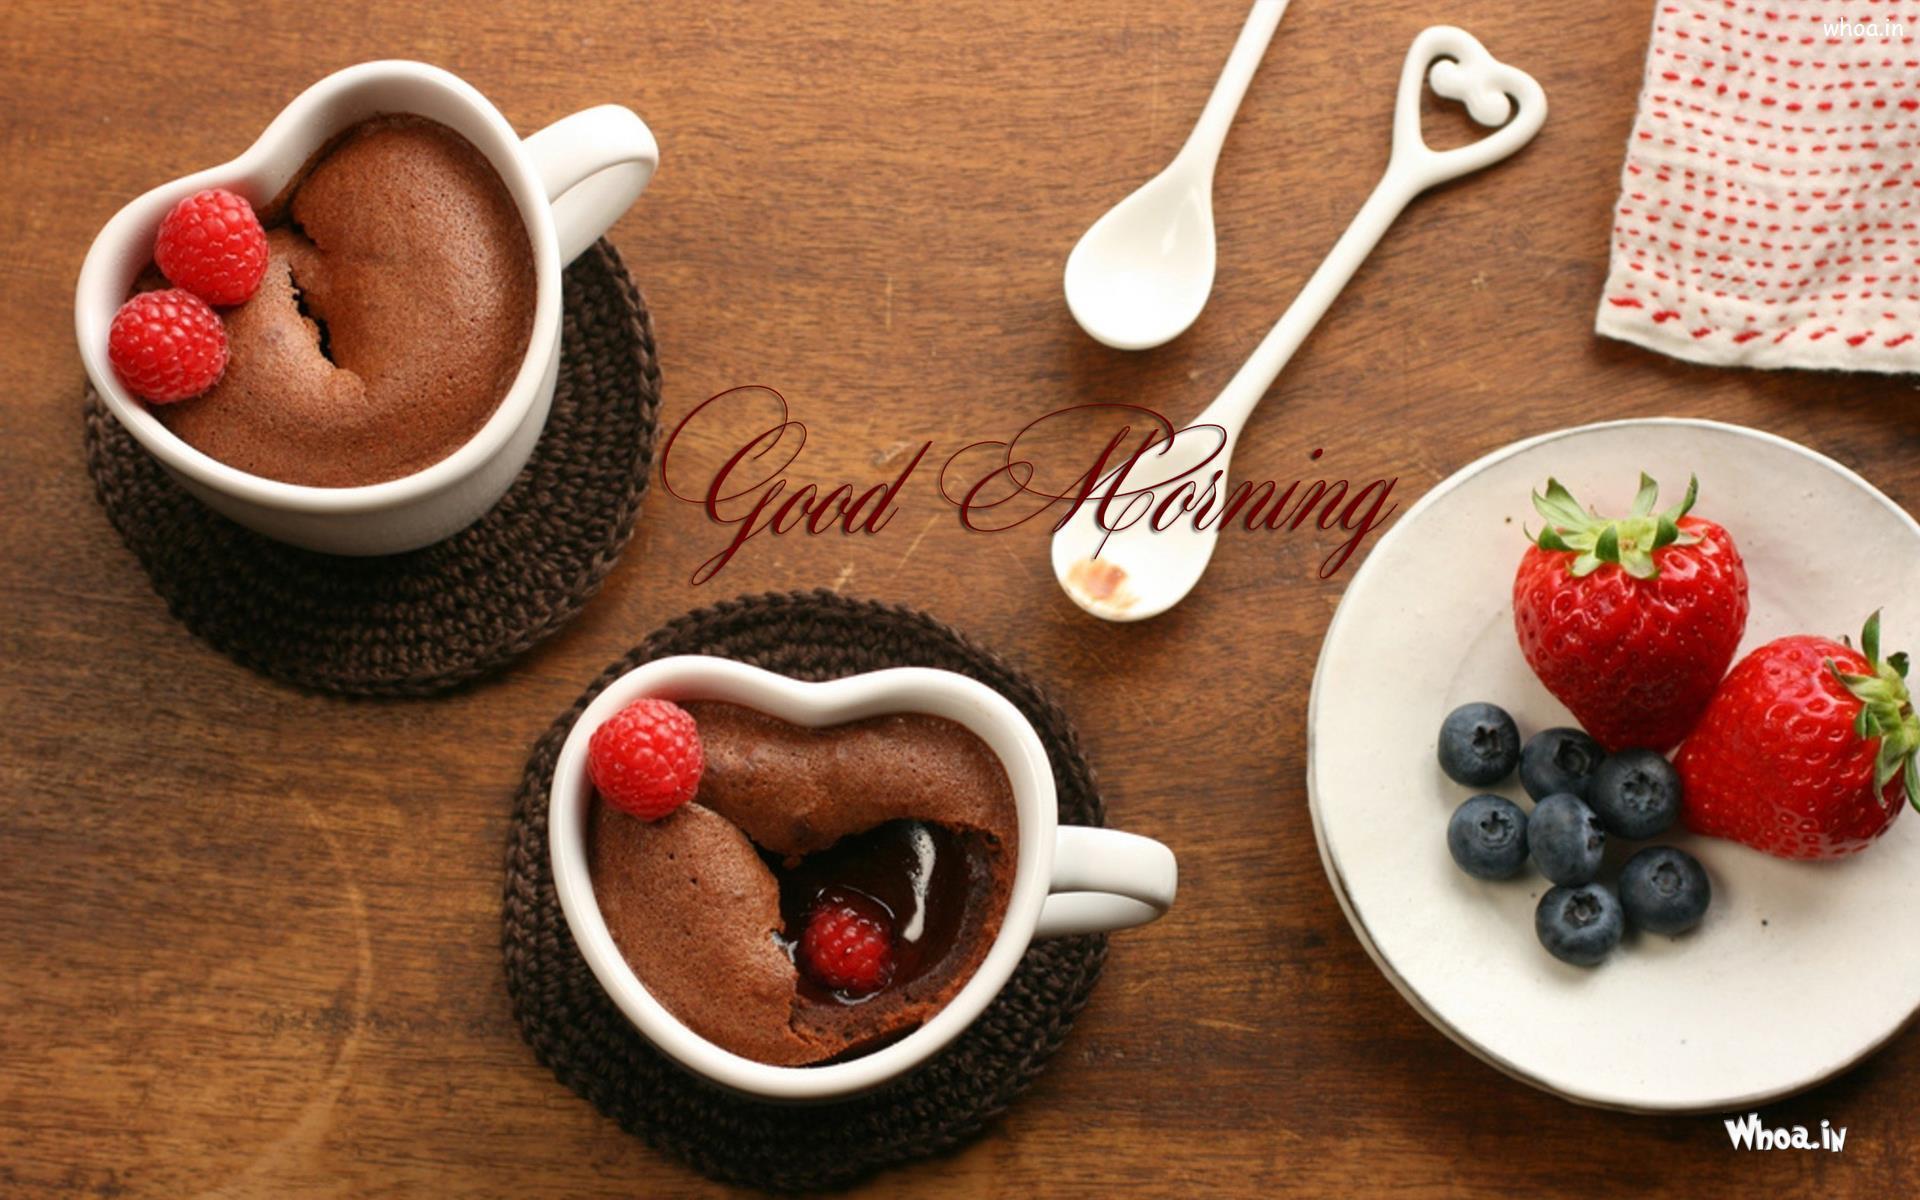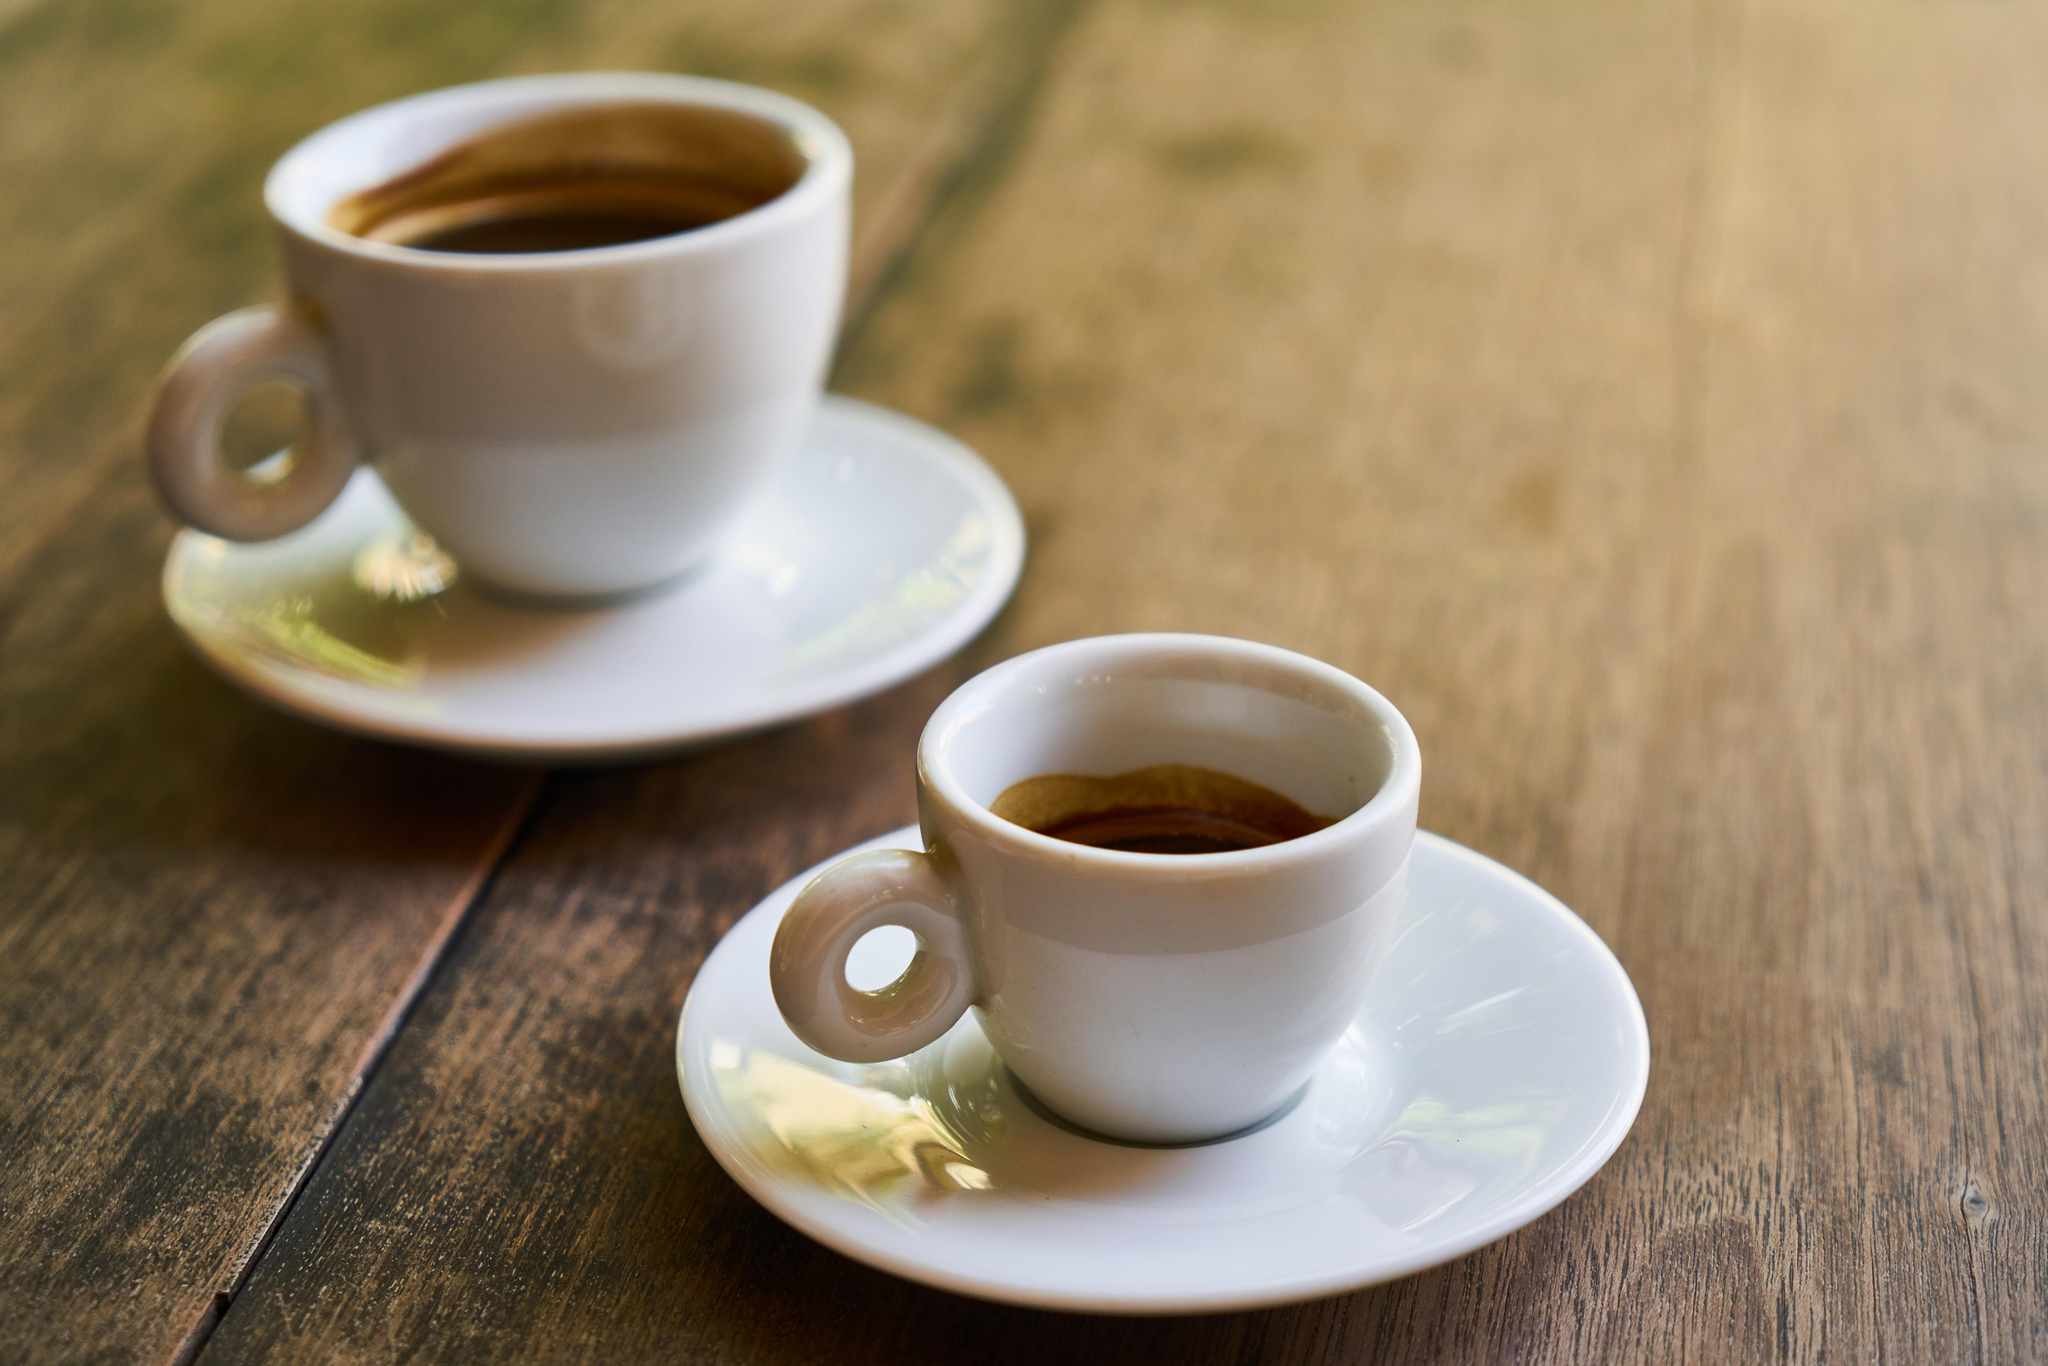The first image is the image on the left, the second image is the image on the right. For the images displayed, is the sentence "There are no more than two cups of coffee in the right image." factually correct? Answer yes or no. Yes. 